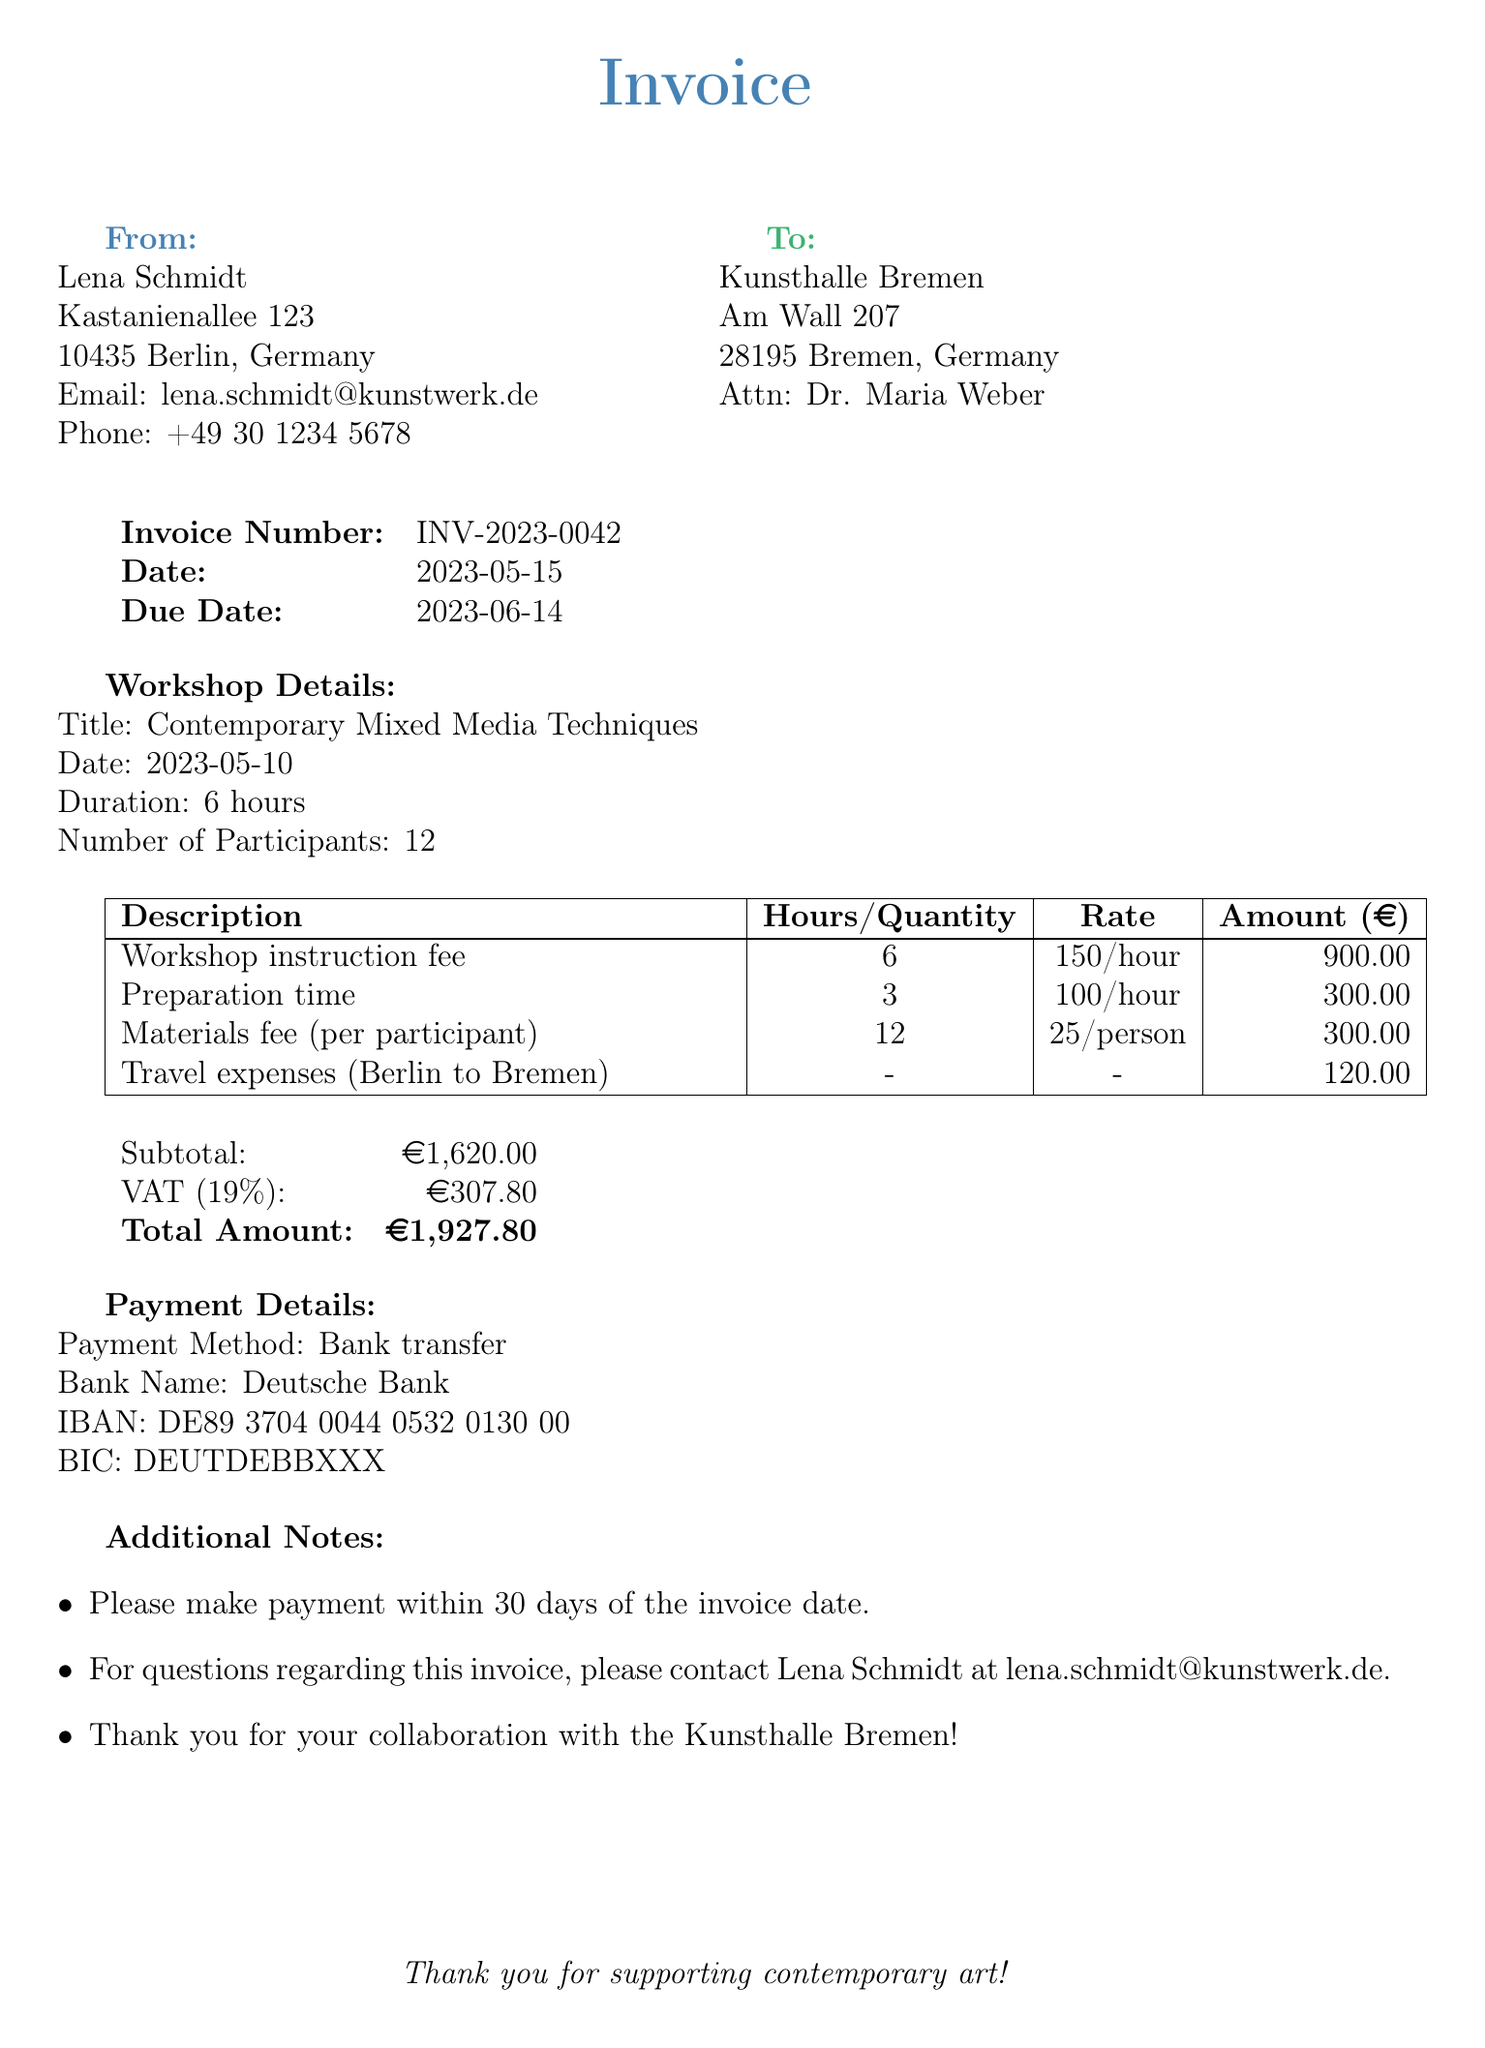what is the invoice number? The invoice number is stated in the document as a unique identifier for the transaction.
Answer: INV-2023-0042 who is the artist? The document provides the name of the artist issuing the invoice, which is Lena Schmidt.
Answer: Lena Schmidt what is the workshop title? The workshop title is highlighted in the details section of the invoice and indicates the subject matter covered in the workshop.
Answer: Contemporary Mixed Media Techniques how many participants attended the workshop? The document mentions the number of individuals who participated in the workshop, which contributes to calculating the total fees.
Answer: 12 what is the total amount due? The total amount due is calculated by adding the subtotal and the VAT as specified in the payment details section.
Answer: 1927.80 what is the preparation time charged? The preparation time is indicated along with the hourly rate and total amount for this line item in the invoice.
Answer: 3 hours what is the VAT rate applied? The VAT rate is a relevant figure for tax calculation, as shown in the payment details of the invoice.
Answer: 19 what is the payment method specified? The document includes a specific method for payments that outlines how the client should settle the invoice.
Answer: Bank transfer what is the due date for the invoice payment? The due date is specified to inform the client of the deadline for making payment against the services rendered.
Answer: 2023-06-14 